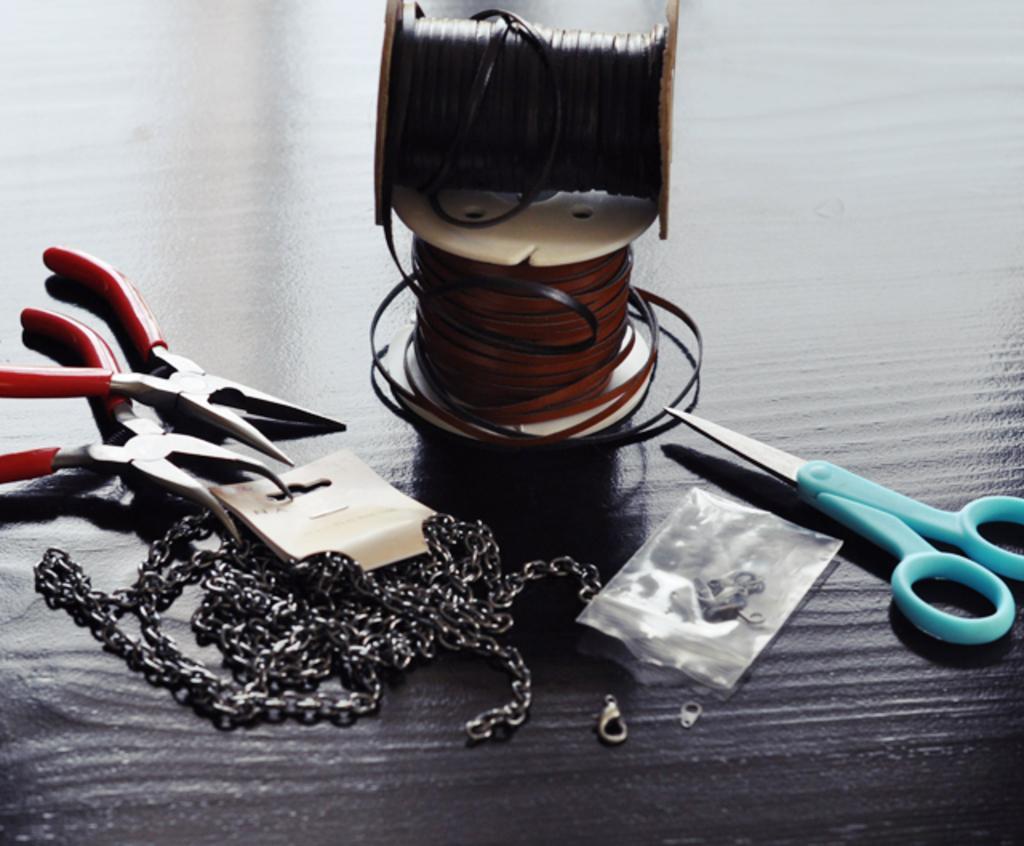How would you summarize this image in a sentence or two? In the image there are two threads, scissors, cutting pliers, chains and other objects kept on a surface. 